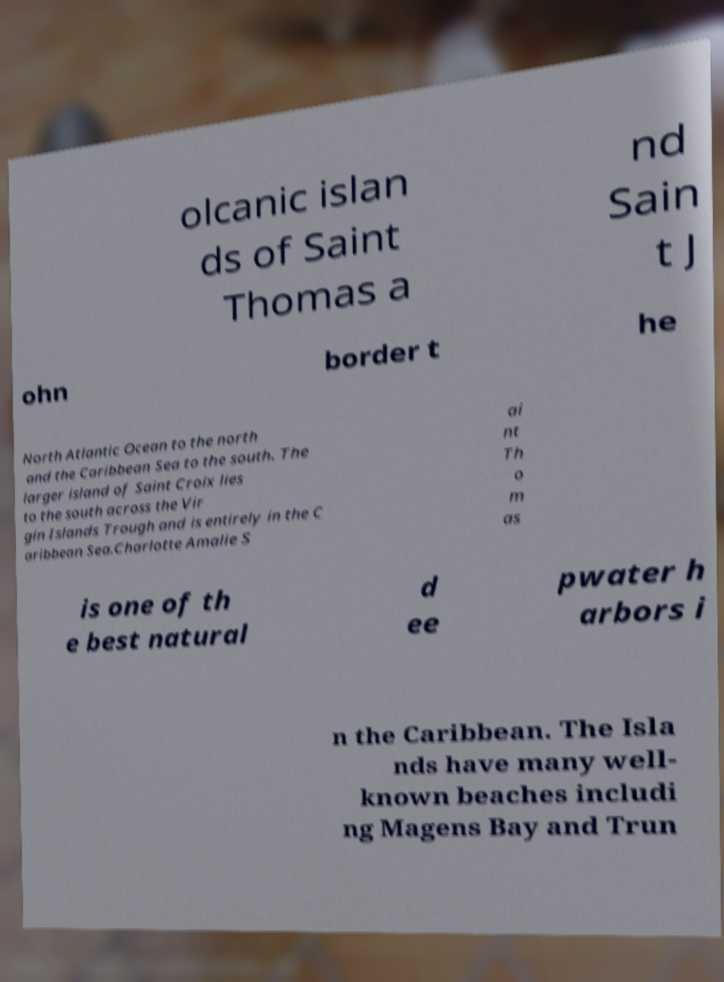Please read and relay the text visible in this image. What does it say? olcanic islan ds of Saint Thomas a nd Sain t J ohn border t he North Atlantic Ocean to the north and the Caribbean Sea to the south. The larger island of Saint Croix lies to the south across the Vir gin Islands Trough and is entirely in the C aribbean Sea.Charlotte Amalie S ai nt Th o m as is one of th e best natural d ee pwater h arbors i n the Caribbean. The Isla nds have many well- known beaches includi ng Magens Bay and Trun 